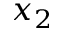<formula> <loc_0><loc_0><loc_500><loc_500>x _ { 2 }</formula> 